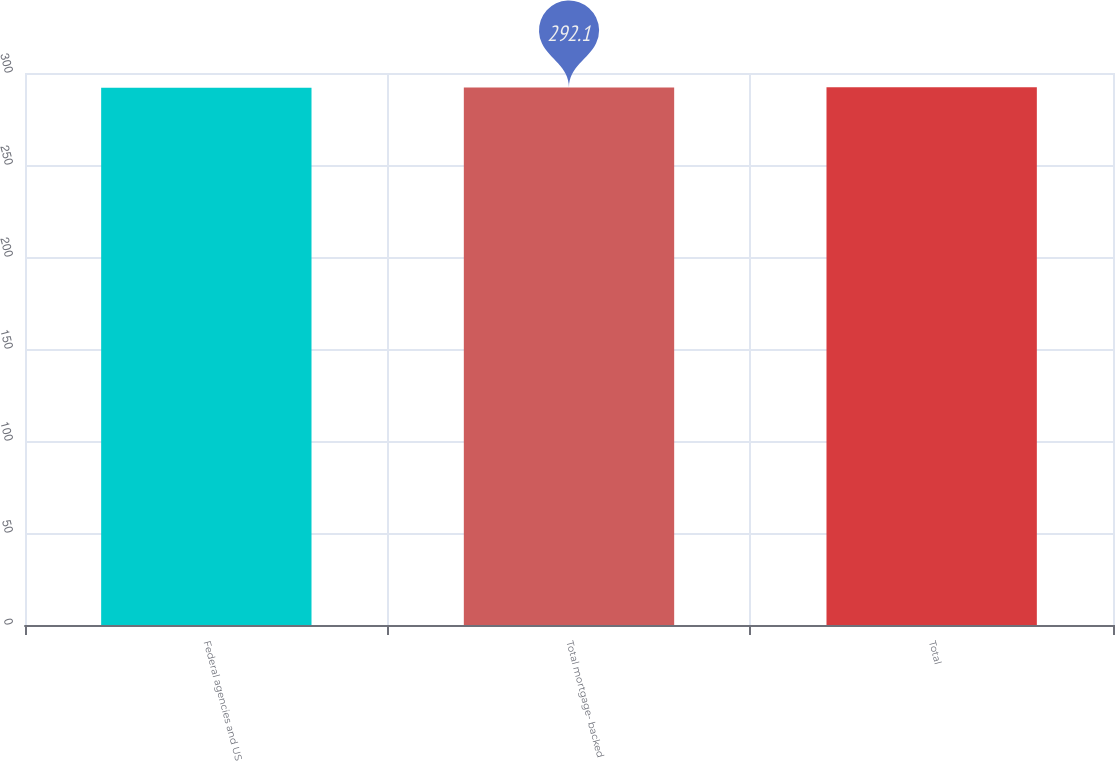Convert chart. <chart><loc_0><loc_0><loc_500><loc_500><bar_chart><fcel>Federal agencies and US<fcel>Total mortgage- backed<fcel>Total<nl><fcel>292<fcel>292.1<fcel>292.2<nl></chart> 